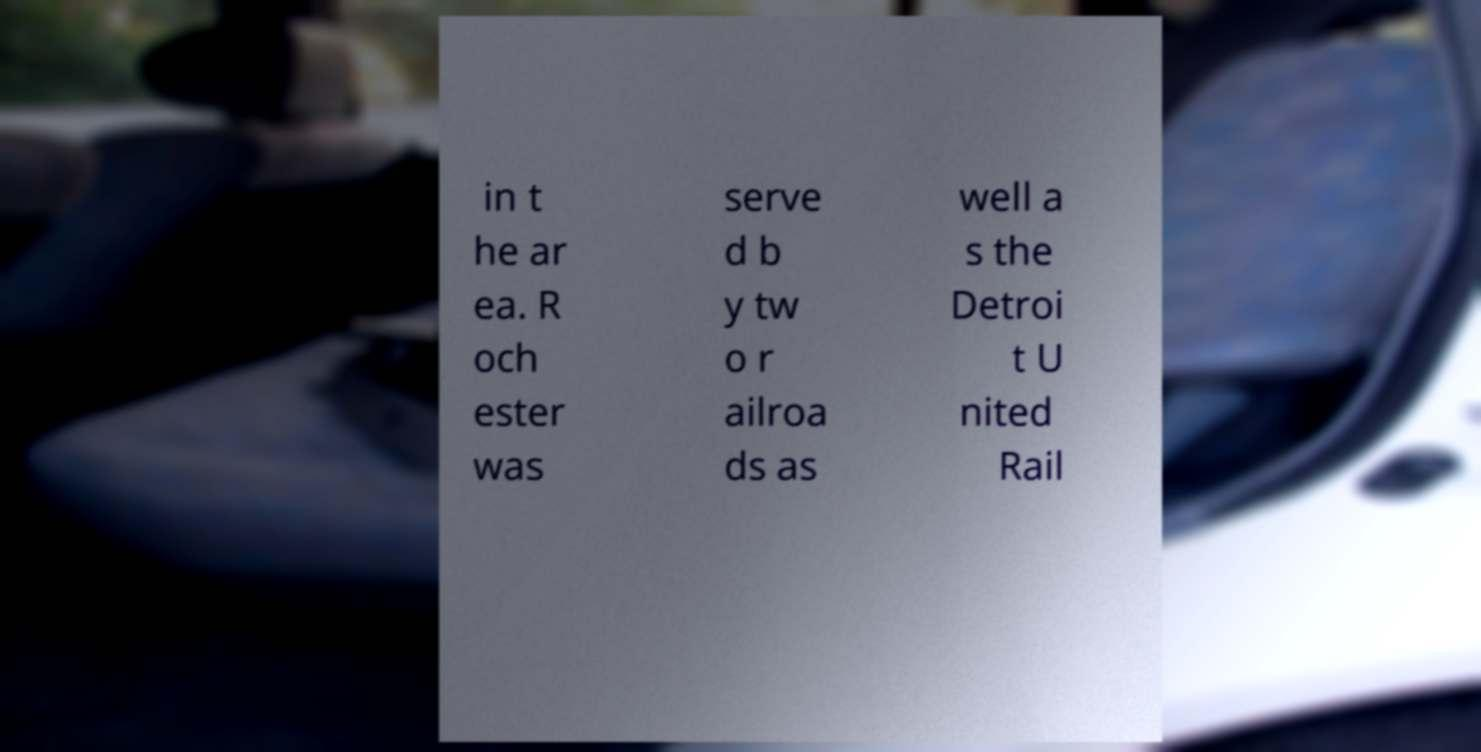I need the written content from this picture converted into text. Can you do that? in t he ar ea. R och ester was serve d b y tw o r ailroa ds as well a s the Detroi t U nited Rail 